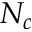<formula> <loc_0><loc_0><loc_500><loc_500>N _ { c }</formula> 